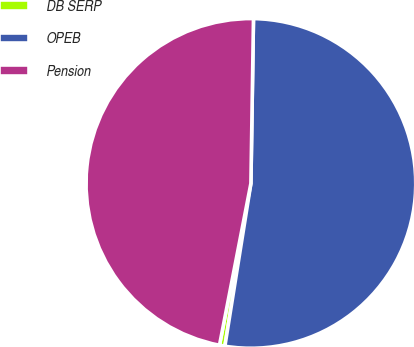<chart> <loc_0><loc_0><loc_500><loc_500><pie_chart><fcel>DB SERP<fcel>OPEB<fcel>Pension<nl><fcel>0.53%<fcel>52.28%<fcel>47.2%<nl></chart> 